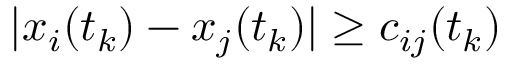Convert formula to latex. <formula><loc_0><loc_0><loc_500><loc_500>| x _ { i } ( t _ { k } ) - x _ { j } ( t _ { k } ) | \geq c _ { i j } ( t _ { k } )</formula> 